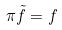Convert formula to latex. <formula><loc_0><loc_0><loc_500><loc_500>\pi \tilde { f } = f</formula> 